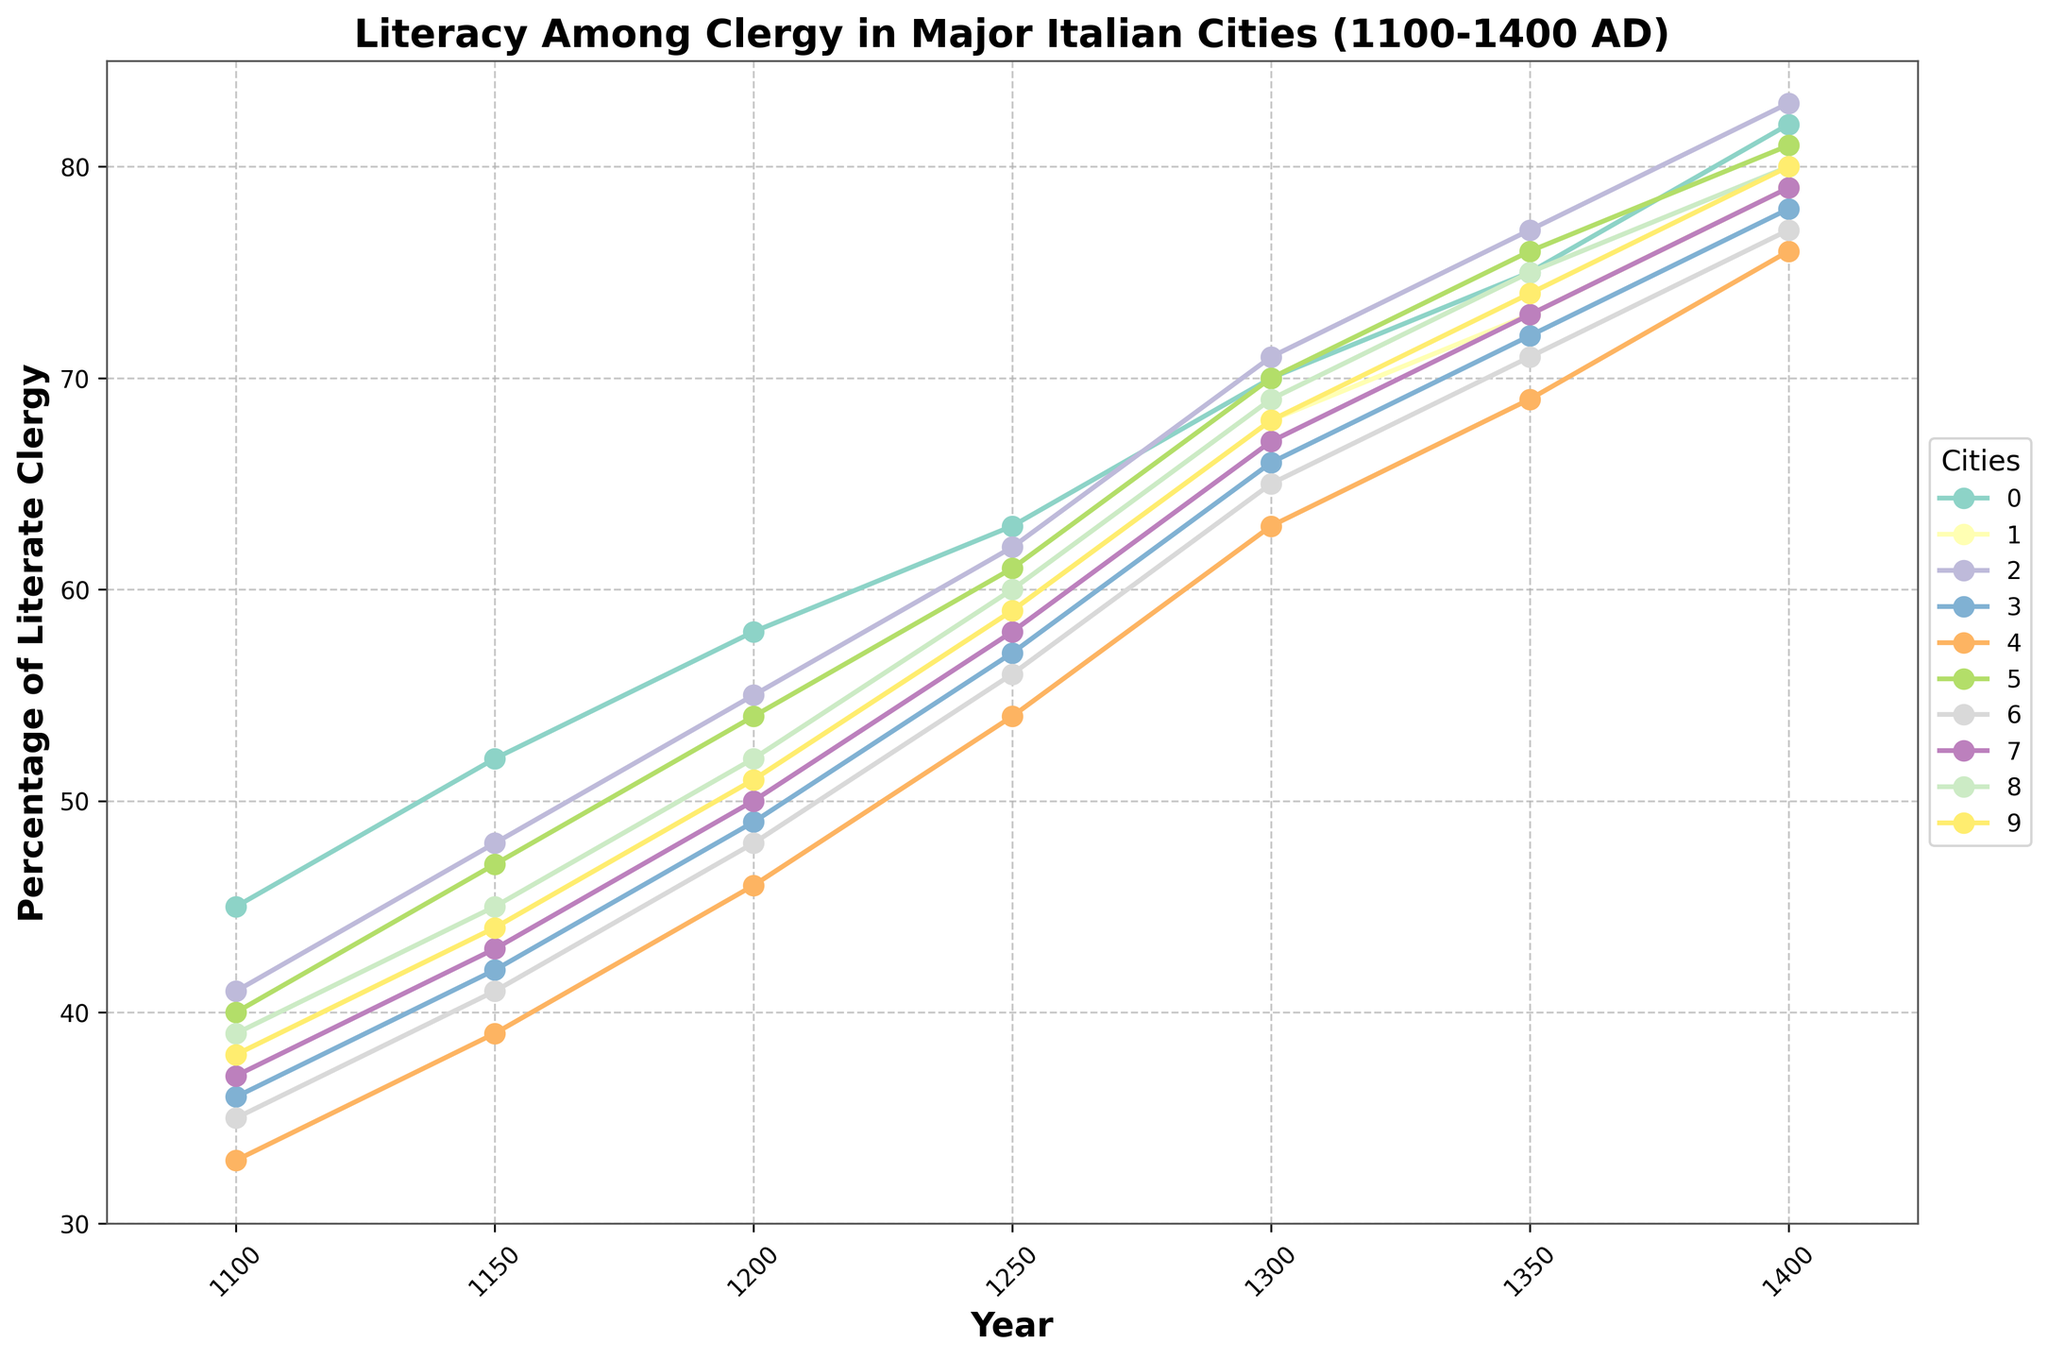Which city had the highest percentage of literate clergy in the year 1400? By looking at the endpoints of the lines on the plot, the line representing Venice ends at the highest point in the 1400 column.
Answer: Venice How did the literacy rate in Florence change between 1300 and 1350? Find the values for Florence at 1300 and 1350, which are 68% and 73%, respectively. Subtract the earlier value from the later one: 73 - 68 = 5.
Answer: Increased by 5% Which city had the lowest percentage of literate clergy in 1100? By looking at the starting points of the lines on the plot, the line representing Naples starts at the lowest point in the 1100 column.
Answer: Naples Compare the literacy rate trends between Rome and Milan over the period 1100 to 1400. Both Rome and Milan show an increasing trend, but Rome consistently has higher literacy rates compared to Milan. Rome begins at 45% in 1100 and reaches 82% in 1400, while Milan starts at 36% and reaches 78% in the same period.
Answer: Rome consistently higher What is the average literacy rate of Bologna across all the years provided? Sum all the values for Bologna (40+47+54+61+70+76+81 = 429) and then divide by the number of years provided: 429/7 = 61.29.
Answer: 61.29% Which cities had a literacy rate of 51% in 1200? Locate the 1200 column and check which lines cross or touch 51%. The cities that meet this criterion are Florence and Padua.
Answer: Florence and Padua Is the literacy rate in Genoa higher or lower than in Pisa in the year 1350? Compare the values of both cities for the year 1350. Genoa is at 75% and Pisa is at 73%.
Answer: Higher Between 1150 and 1200, which city saw the greatest increase in literacy rate? Calculate the differences between 1200 and 1150 for each city and identify the greatest increase: 
- Rome: 58 - 52 = 6
- Florence: 51 - 44 = 7
- Venice: 55 - 48 = 7
- Milan: 49 - 42 = 7
- Naples: 46 - 39 = 7
- Bologna: 54 - 47 = 7
- Siena: 48 - 41 = 7
- Pisa: 50 - 43 = 7
- Genoa: 52 - 45 = 7
- Padua: 51 - 44 = 7
Since multiple cities have the greatest increase of 7%, any of these cities counts.
Answer: Florence, Venice, Milan, Naples, Bologna, Siena, Pisa, Genoa, or Padua What is the difference between the literacy rates of Naples and Rome in 1400? Find the values for Naples and Rome in 1400: 76% for Naples and 82% for Rome. Subtract the value for Naples from the value for Rome: 82 - 76 = 6.
Answer: 6% Identify a period when the literacy rate in Siena surpassed that of Milan. By examining the lines for Siena and Milan, observe that Siena's literacy rate surpasses Milan's rate around 1350 when Siena's rate is 71% and Milan's is 72%.
Answer: Around 1350 